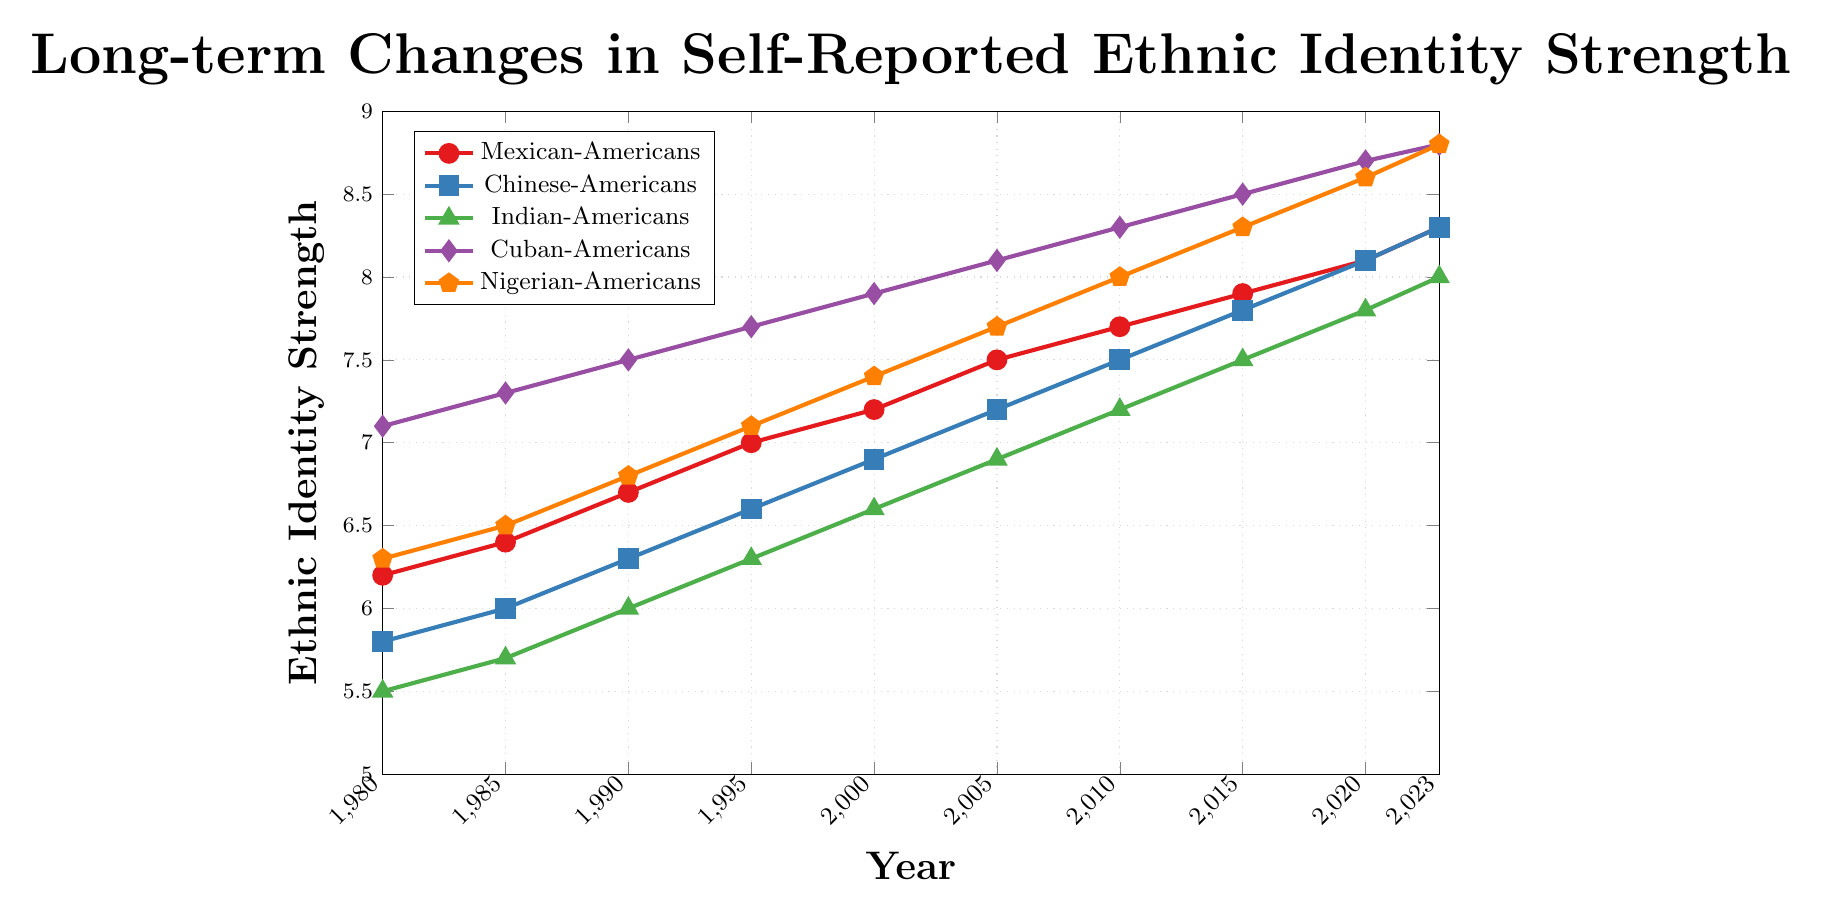Which group shows the highest increase in ethnic identity strength from 1980 to 2023? By examining the end values of each group's line, Cuban-Americans have the highest final value and started with already high initial value, indicating the largest absolute increase. The increase is 8.8 - 7.1 = 1.7 for Cuban-Americans, while Mexican-Americans increased from 6.2 to 8.3 (2.1), Chinese-Americans from 5.8 to 8.3 (2.5), Indian-Americans from 5.5 to 8.0 (2.5), and Nigerian-Americans from 6.3 to 8.8 (2.5).
Answer: Cuban-Americans What is the average ethnic identity strength for Indian-Americans across all years? Sum the values for Indian-Americans at each data point (5.5, 5.7, 6.0, 6.3, 6.6, 6.9, 7.2, 7.5, 7.8, 8.0) and divide by the number of points (10). The sum is 67.5, so the average is 67.5 / 10 = 6.75.
Answer: 6.75 Which groups have the same ethnic identity strength in the year 2023? Look at the y-values for the year 2023 and compare. Both Chinese-Americans and Mexican-Americans have an ethnic identity strength of 8.3.
Answer: Chinese-Americans, Mexican-Americans How does the ethnic identity strength of Nigerian-Americans in 2000 compare to that of Cuban-Americans in 1995? Find the values for Nigerian-Americans in 2000 (7.4) and Cuban-Americans in 1995 (7.7). Comparing these values shows that Cuban-Americans had a higher ethnic identity strength in 1995 (7.7 > 7.4).
Answer: Cuban-Americans in 1995 is higher Which group has the most consistent (least fluctuating) increase in ethnic identity strength over the period 1980-2023? Consistency is judged by smoothness of the increase. All groups show a consistent rise, but since we are focusing on smoothness and regular increments, Mexican-Americans show a nearly linear progression without any fluctuation from year to year.
Answer: Mexican-Americans What is the total increase in ethnic identity strength for Chinese-Americans from 1980 to 2023? Subtract the 1980 value from the 2023 value for Chinese-Americans: 8.3 - 5.8 = 2.5.
Answer: 2.5 Between 2010 and 2015, which group saw the largest increase in ethnic identity strength? Calculate the difference between the 2015 and 2010 values for each group. Mexican-Americans: 7.9 - 7.7 = 0.2, Chinese-Americans: 7.8 - 7.5 = 0.3, Indian-Americans: 7.5 - 7.2 = 0.3, Cuban-Americans: 8.5 - 8.3 = 0.2, Nigerian-Americans: 8.3 - 8.0 = 0.3. The largest increase is 0.3, observed in Chinese-Americans, Indian-Americans, and Nigerian-Americans.
Answer: Chinese-Americans, Indian-Americans, Nigerian-Americans 